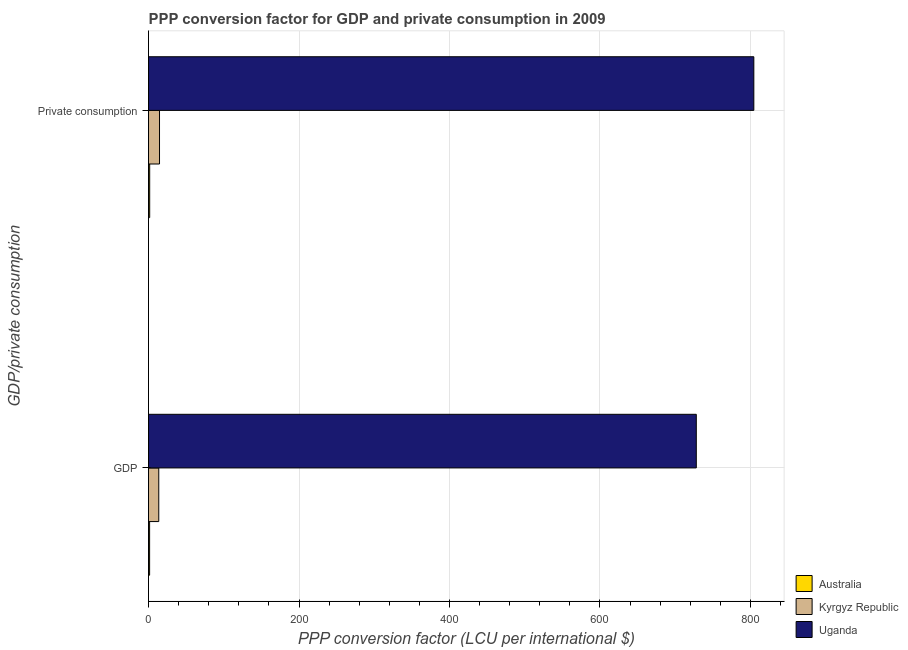Are the number of bars per tick equal to the number of legend labels?
Your response must be concise. Yes. How many bars are there on the 1st tick from the top?
Make the answer very short. 3. What is the label of the 2nd group of bars from the top?
Offer a terse response. GDP. What is the ppp conversion factor for private consumption in Kyrgyz Republic?
Provide a succinct answer. 14.62. Across all countries, what is the maximum ppp conversion factor for gdp?
Provide a short and direct response. 727.98. Across all countries, what is the minimum ppp conversion factor for gdp?
Your response must be concise. 1.44. In which country was the ppp conversion factor for gdp maximum?
Keep it short and to the point. Uganda. What is the total ppp conversion factor for private consumption in the graph?
Provide a succinct answer. 820.62. What is the difference between the ppp conversion factor for gdp in Kyrgyz Republic and that in Australia?
Offer a very short reply. 12.17. What is the difference between the ppp conversion factor for private consumption in Australia and the ppp conversion factor for gdp in Kyrgyz Republic?
Your response must be concise. -12.07. What is the average ppp conversion factor for gdp per country?
Make the answer very short. 247.68. What is the difference between the ppp conversion factor for private consumption and ppp conversion factor for gdp in Kyrgyz Republic?
Keep it short and to the point. 1.01. In how many countries, is the ppp conversion factor for gdp greater than 600 LCU?
Offer a very short reply. 1. What is the ratio of the ppp conversion factor for gdp in Australia to that in Kyrgyz Republic?
Give a very brief answer. 0.11. What does the 1st bar from the top in  Private consumption represents?
Provide a short and direct response. Uganda. What does the 2nd bar from the bottom in  Private consumption represents?
Offer a very short reply. Kyrgyz Republic. Are the values on the major ticks of X-axis written in scientific E-notation?
Offer a terse response. No. Does the graph contain grids?
Give a very brief answer. Yes. What is the title of the graph?
Keep it short and to the point. PPP conversion factor for GDP and private consumption in 2009. What is the label or title of the X-axis?
Your answer should be very brief. PPP conversion factor (LCU per international $). What is the label or title of the Y-axis?
Your answer should be very brief. GDP/private consumption. What is the PPP conversion factor (LCU per international $) of Australia in GDP?
Give a very brief answer. 1.44. What is the PPP conversion factor (LCU per international $) of Kyrgyz Republic in GDP?
Your answer should be very brief. 13.61. What is the PPP conversion factor (LCU per international $) in Uganda in GDP?
Make the answer very short. 727.98. What is the PPP conversion factor (LCU per international $) of Australia in  Private consumption?
Offer a terse response. 1.54. What is the PPP conversion factor (LCU per international $) in Kyrgyz Republic in  Private consumption?
Offer a terse response. 14.62. What is the PPP conversion factor (LCU per international $) of Uganda in  Private consumption?
Give a very brief answer. 804.46. Across all GDP/private consumption, what is the maximum PPP conversion factor (LCU per international $) of Australia?
Give a very brief answer. 1.54. Across all GDP/private consumption, what is the maximum PPP conversion factor (LCU per international $) of Kyrgyz Republic?
Provide a succinct answer. 14.62. Across all GDP/private consumption, what is the maximum PPP conversion factor (LCU per international $) in Uganda?
Keep it short and to the point. 804.46. Across all GDP/private consumption, what is the minimum PPP conversion factor (LCU per international $) of Australia?
Keep it short and to the point. 1.44. Across all GDP/private consumption, what is the minimum PPP conversion factor (LCU per international $) of Kyrgyz Republic?
Provide a short and direct response. 13.61. Across all GDP/private consumption, what is the minimum PPP conversion factor (LCU per international $) of Uganda?
Your answer should be compact. 727.98. What is the total PPP conversion factor (LCU per international $) of Australia in the graph?
Your answer should be very brief. 2.99. What is the total PPP conversion factor (LCU per international $) in Kyrgyz Republic in the graph?
Ensure brevity in your answer.  28.23. What is the total PPP conversion factor (LCU per international $) of Uganda in the graph?
Your answer should be very brief. 1532.44. What is the difference between the PPP conversion factor (LCU per international $) of Australia in GDP and that in  Private consumption?
Your answer should be compact. -0.1. What is the difference between the PPP conversion factor (LCU per international $) in Kyrgyz Republic in GDP and that in  Private consumption?
Your answer should be compact. -1.01. What is the difference between the PPP conversion factor (LCU per international $) of Uganda in GDP and that in  Private consumption?
Your answer should be compact. -76.48. What is the difference between the PPP conversion factor (LCU per international $) in Australia in GDP and the PPP conversion factor (LCU per international $) in Kyrgyz Republic in  Private consumption?
Your response must be concise. -13.18. What is the difference between the PPP conversion factor (LCU per international $) in Australia in GDP and the PPP conversion factor (LCU per international $) in Uganda in  Private consumption?
Your answer should be compact. -803.01. What is the difference between the PPP conversion factor (LCU per international $) of Kyrgyz Republic in GDP and the PPP conversion factor (LCU per international $) of Uganda in  Private consumption?
Offer a terse response. -790.84. What is the average PPP conversion factor (LCU per international $) of Australia per GDP/private consumption?
Your answer should be compact. 1.49. What is the average PPP conversion factor (LCU per international $) of Kyrgyz Republic per GDP/private consumption?
Make the answer very short. 14.12. What is the average PPP conversion factor (LCU per international $) in Uganda per GDP/private consumption?
Give a very brief answer. 766.22. What is the difference between the PPP conversion factor (LCU per international $) in Australia and PPP conversion factor (LCU per international $) in Kyrgyz Republic in GDP?
Your answer should be compact. -12.17. What is the difference between the PPP conversion factor (LCU per international $) in Australia and PPP conversion factor (LCU per international $) in Uganda in GDP?
Offer a very short reply. -726.54. What is the difference between the PPP conversion factor (LCU per international $) of Kyrgyz Republic and PPP conversion factor (LCU per international $) of Uganda in GDP?
Offer a very short reply. -714.37. What is the difference between the PPP conversion factor (LCU per international $) of Australia and PPP conversion factor (LCU per international $) of Kyrgyz Republic in  Private consumption?
Your answer should be very brief. -13.08. What is the difference between the PPP conversion factor (LCU per international $) in Australia and PPP conversion factor (LCU per international $) in Uganda in  Private consumption?
Your answer should be compact. -802.91. What is the difference between the PPP conversion factor (LCU per international $) of Kyrgyz Republic and PPP conversion factor (LCU per international $) of Uganda in  Private consumption?
Your answer should be compact. -789.84. What is the ratio of the PPP conversion factor (LCU per international $) in Australia in GDP to that in  Private consumption?
Ensure brevity in your answer.  0.94. What is the ratio of the PPP conversion factor (LCU per international $) in Kyrgyz Republic in GDP to that in  Private consumption?
Ensure brevity in your answer.  0.93. What is the ratio of the PPP conversion factor (LCU per international $) of Uganda in GDP to that in  Private consumption?
Make the answer very short. 0.9. What is the difference between the highest and the second highest PPP conversion factor (LCU per international $) of Australia?
Your answer should be very brief. 0.1. What is the difference between the highest and the second highest PPP conversion factor (LCU per international $) in Kyrgyz Republic?
Offer a terse response. 1.01. What is the difference between the highest and the second highest PPP conversion factor (LCU per international $) of Uganda?
Provide a succinct answer. 76.48. What is the difference between the highest and the lowest PPP conversion factor (LCU per international $) of Australia?
Offer a terse response. 0.1. What is the difference between the highest and the lowest PPP conversion factor (LCU per international $) of Kyrgyz Republic?
Your answer should be very brief. 1.01. What is the difference between the highest and the lowest PPP conversion factor (LCU per international $) of Uganda?
Your answer should be very brief. 76.48. 